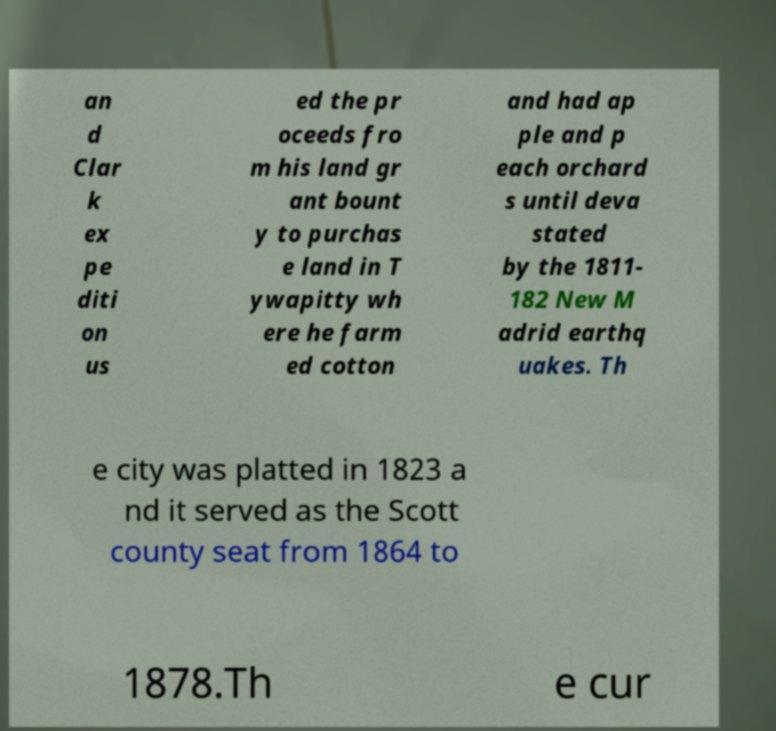Can you accurately transcribe the text from the provided image for me? an d Clar k ex pe diti on us ed the pr oceeds fro m his land gr ant bount y to purchas e land in T ywapitty wh ere he farm ed cotton and had ap ple and p each orchard s until deva stated by the 1811- 182 New M adrid earthq uakes. Th e city was platted in 1823 a nd it served as the Scott county seat from 1864 to 1878.Th e cur 